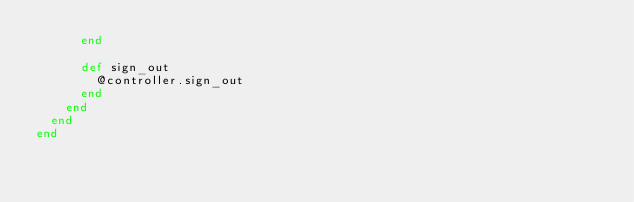<code> <loc_0><loc_0><loc_500><loc_500><_Ruby_>      end

      def sign_out
        @controller.sign_out
      end
    end
  end
end
</code> 